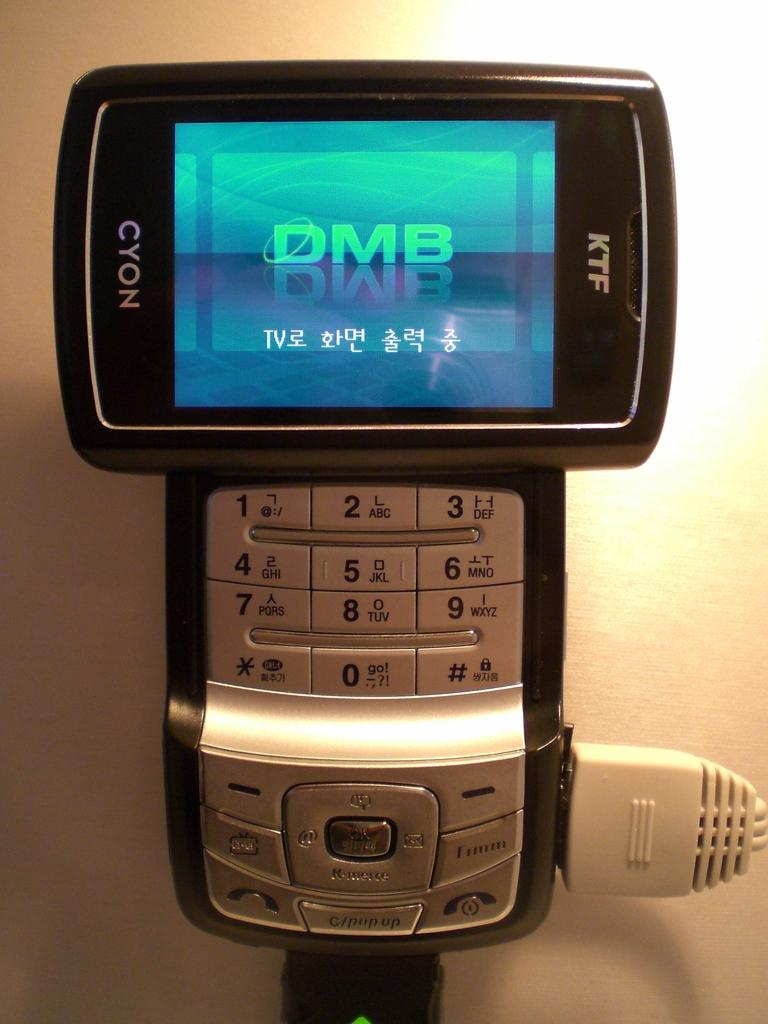<image>
Share a concise interpretation of the image provided. A black and gray Cyon brand twist cell phone with the screen displaying DMB 